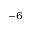Convert formula to latex. <formula><loc_0><loc_0><loc_500><loc_500>^ { - 6 }</formula> 